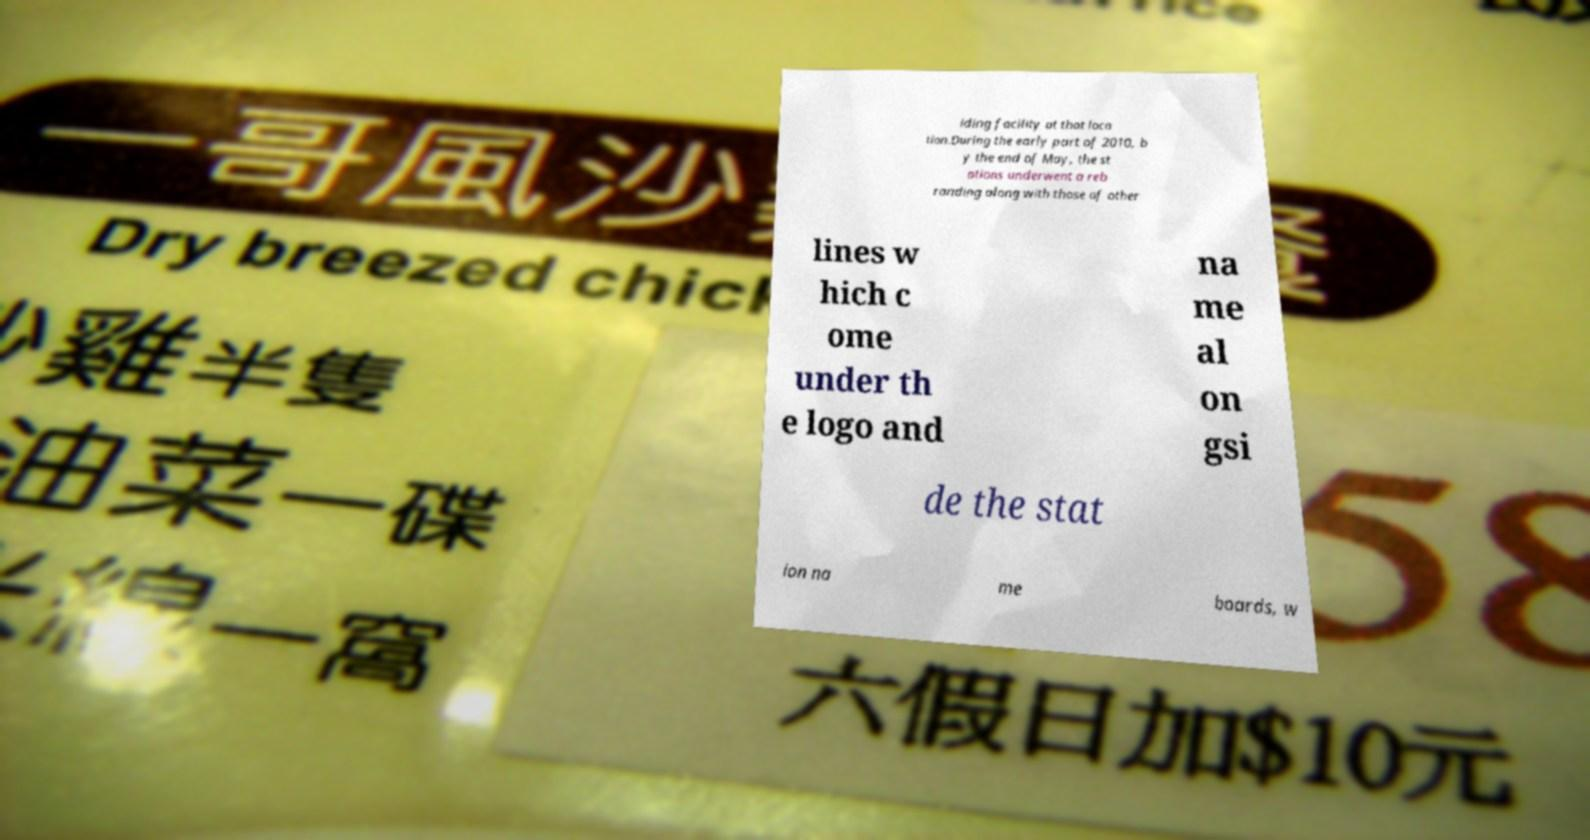I need the written content from this picture converted into text. Can you do that? iding facility at that loca tion.During the early part of 2010, b y the end of May, the st ations underwent a reb randing along with those of other lines w hich c ome under th e logo and na me al on gsi de the stat ion na me boards, w 